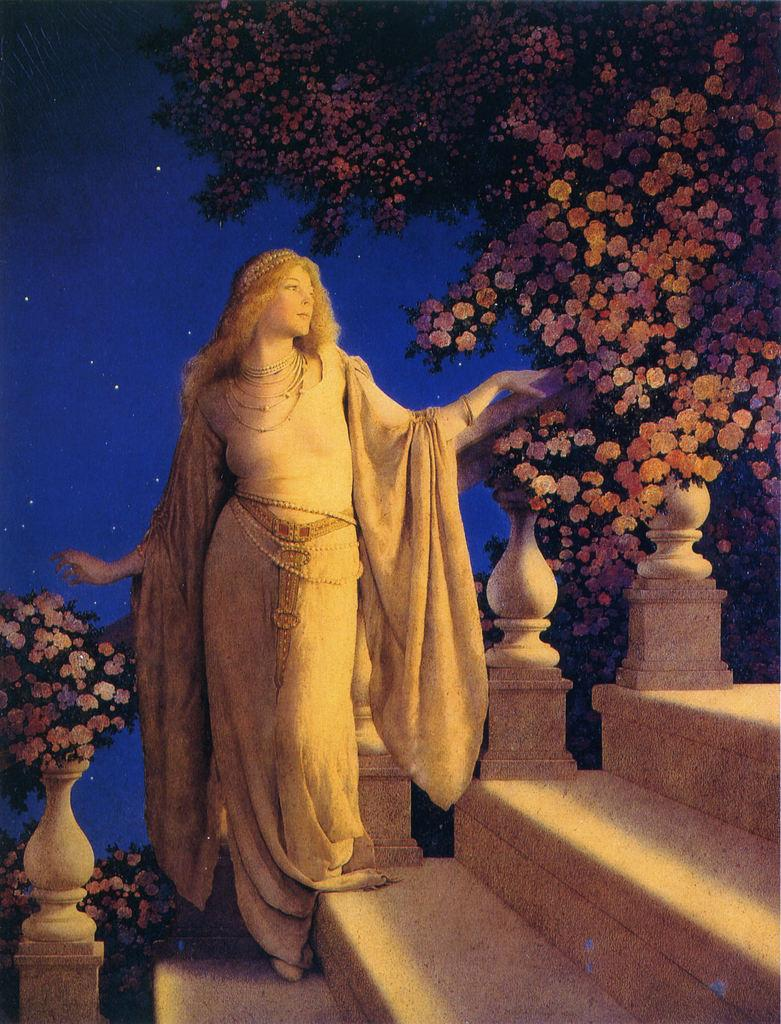What type of visual is the image? The image is a poster. What can be seen on the poster? There is a woman standing on the steps and a tree with flowers in the image. What is visible in the sky? Stars are visible in the sky. What is the price of the wheel in the image? There is no wheel present in the image, so it is not possible to determine its price. 